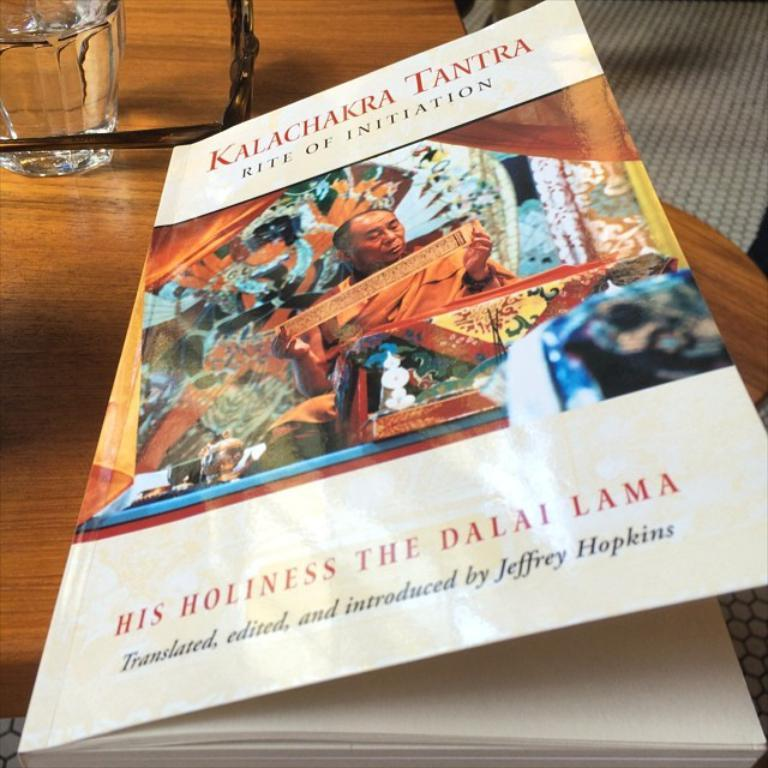<image>
Offer a succinct explanation of the picture presented. A book sitting on table, the title says Kalachakra Tantra 